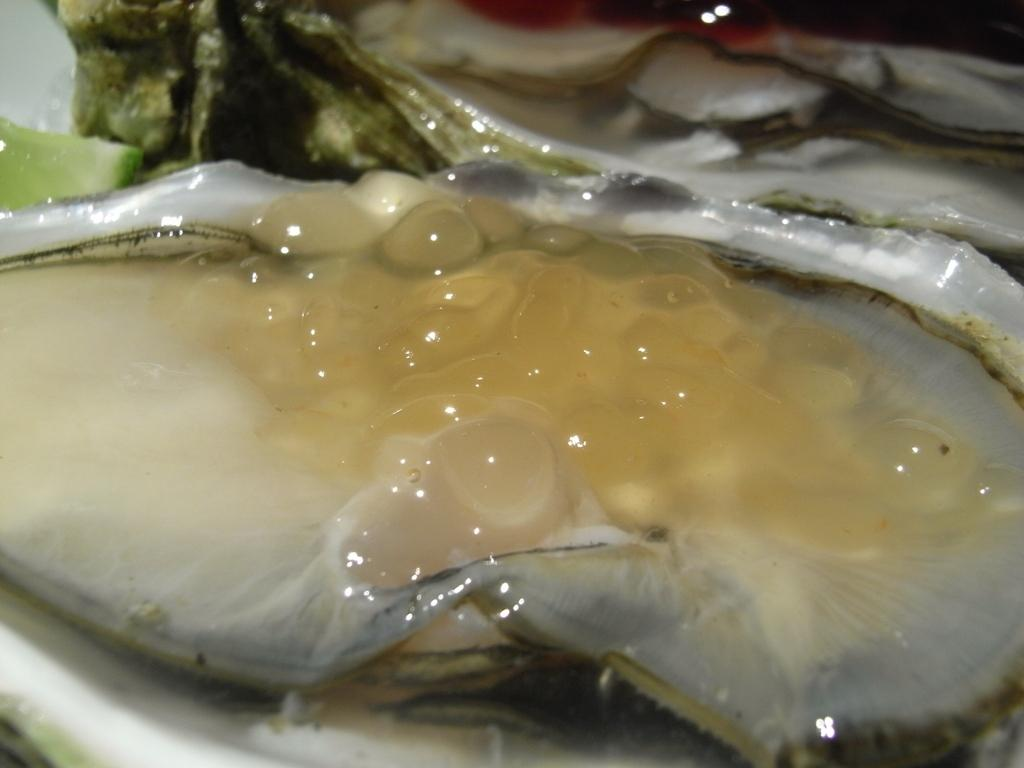What is the main subject of the image? There is an oyster in the image. What is the name of the town where the oyster is located in the image? There is no town mentioned or visible in the image; it only features an oyster. 